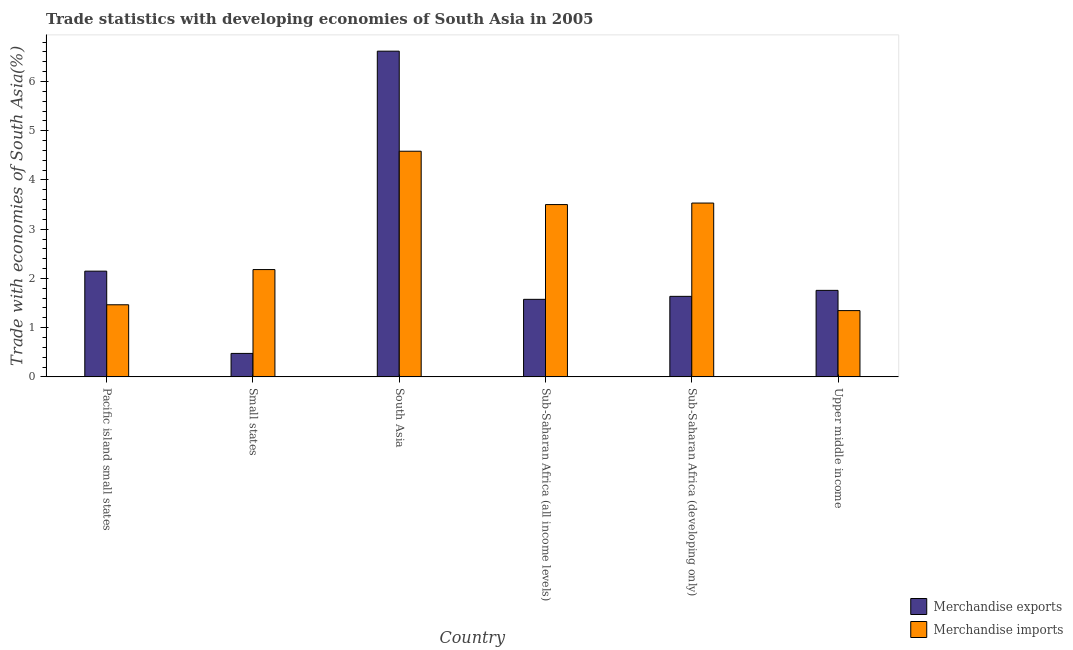How many different coloured bars are there?
Give a very brief answer. 2. Are the number of bars per tick equal to the number of legend labels?
Make the answer very short. Yes. Are the number of bars on each tick of the X-axis equal?
Your response must be concise. Yes. How many bars are there on the 6th tick from the right?
Make the answer very short. 2. What is the label of the 1st group of bars from the left?
Make the answer very short. Pacific island small states. In how many cases, is the number of bars for a given country not equal to the number of legend labels?
Your answer should be very brief. 0. What is the merchandise imports in Sub-Saharan Africa (developing only)?
Provide a succinct answer. 3.53. Across all countries, what is the maximum merchandise exports?
Give a very brief answer. 6.62. Across all countries, what is the minimum merchandise exports?
Keep it short and to the point. 0.48. In which country was the merchandise exports minimum?
Provide a short and direct response. Small states. What is the total merchandise exports in the graph?
Your answer should be very brief. 14.21. What is the difference between the merchandise exports in Pacific island small states and that in Sub-Saharan Africa (all income levels)?
Offer a terse response. 0.57. What is the difference between the merchandise imports in Sub-Saharan Africa (all income levels) and the merchandise exports in Upper middle income?
Provide a short and direct response. 1.74. What is the average merchandise imports per country?
Your response must be concise. 2.77. What is the difference between the merchandise exports and merchandise imports in Pacific island small states?
Offer a very short reply. 0.68. In how many countries, is the merchandise exports greater than 6 %?
Your answer should be very brief. 1. What is the ratio of the merchandise imports in Pacific island small states to that in Sub-Saharan Africa (developing only)?
Provide a short and direct response. 0.41. What is the difference between the highest and the second highest merchandise exports?
Provide a short and direct response. 4.47. What is the difference between the highest and the lowest merchandise exports?
Your answer should be compact. 6.14. Is the sum of the merchandise imports in South Asia and Sub-Saharan Africa (developing only) greater than the maximum merchandise exports across all countries?
Ensure brevity in your answer.  Yes. What does the 2nd bar from the left in Sub-Saharan Africa (developing only) represents?
Ensure brevity in your answer.  Merchandise imports. What does the 1st bar from the right in Small states represents?
Your response must be concise. Merchandise imports. How many bars are there?
Your answer should be very brief. 12. Are all the bars in the graph horizontal?
Your answer should be very brief. No. How many countries are there in the graph?
Ensure brevity in your answer.  6. Are the values on the major ticks of Y-axis written in scientific E-notation?
Your answer should be very brief. No. Does the graph contain any zero values?
Your answer should be very brief. No. Does the graph contain grids?
Your answer should be very brief. No. Where does the legend appear in the graph?
Provide a short and direct response. Bottom right. What is the title of the graph?
Give a very brief answer. Trade statistics with developing economies of South Asia in 2005. Does "Long-term debt" appear as one of the legend labels in the graph?
Your answer should be compact. No. What is the label or title of the X-axis?
Your answer should be very brief. Country. What is the label or title of the Y-axis?
Keep it short and to the point. Trade with economies of South Asia(%). What is the Trade with economies of South Asia(%) of Merchandise exports in Pacific island small states?
Provide a succinct answer. 2.15. What is the Trade with economies of South Asia(%) of Merchandise imports in Pacific island small states?
Keep it short and to the point. 1.46. What is the Trade with economies of South Asia(%) of Merchandise exports in Small states?
Give a very brief answer. 0.48. What is the Trade with economies of South Asia(%) of Merchandise imports in Small states?
Offer a terse response. 2.18. What is the Trade with economies of South Asia(%) in Merchandise exports in South Asia?
Your answer should be compact. 6.62. What is the Trade with economies of South Asia(%) in Merchandise imports in South Asia?
Ensure brevity in your answer.  4.58. What is the Trade with economies of South Asia(%) in Merchandise exports in Sub-Saharan Africa (all income levels)?
Ensure brevity in your answer.  1.57. What is the Trade with economies of South Asia(%) of Merchandise imports in Sub-Saharan Africa (all income levels)?
Provide a short and direct response. 3.5. What is the Trade with economies of South Asia(%) in Merchandise exports in Sub-Saharan Africa (developing only)?
Your answer should be very brief. 1.64. What is the Trade with economies of South Asia(%) of Merchandise imports in Sub-Saharan Africa (developing only)?
Your answer should be very brief. 3.53. What is the Trade with economies of South Asia(%) of Merchandise exports in Upper middle income?
Ensure brevity in your answer.  1.76. What is the Trade with economies of South Asia(%) in Merchandise imports in Upper middle income?
Your answer should be compact. 1.35. Across all countries, what is the maximum Trade with economies of South Asia(%) in Merchandise exports?
Offer a terse response. 6.62. Across all countries, what is the maximum Trade with economies of South Asia(%) in Merchandise imports?
Give a very brief answer. 4.58. Across all countries, what is the minimum Trade with economies of South Asia(%) of Merchandise exports?
Offer a very short reply. 0.48. Across all countries, what is the minimum Trade with economies of South Asia(%) in Merchandise imports?
Provide a succinct answer. 1.35. What is the total Trade with economies of South Asia(%) of Merchandise exports in the graph?
Offer a terse response. 14.21. What is the total Trade with economies of South Asia(%) in Merchandise imports in the graph?
Provide a short and direct response. 16.6. What is the difference between the Trade with economies of South Asia(%) in Merchandise exports in Pacific island small states and that in Small states?
Offer a very short reply. 1.67. What is the difference between the Trade with economies of South Asia(%) of Merchandise imports in Pacific island small states and that in Small states?
Your answer should be compact. -0.72. What is the difference between the Trade with economies of South Asia(%) in Merchandise exports in Pacific island small states and that in South Asia?
Give a very brief answer. -4.47. What is the difference between the Trade with economies of South Asia(%) in Merchandise imports in Pacific island small states and that in South Asia?
Your response must be concise. -3.12. What is the difference between the Trade with economies of South Asia(%) of Merchandise exports in Pacific island small states and that in Sub-Saharan Africa (all income levels)?
Keep it short and to the point. 0.57. What is the difference between the Trade with economies of South Asia(%) in Merchandise imports in Pacific island small states and that in Sub-Saharan Africa (all income levels)?
Provide a succinct answer. -2.04. What is the difference between the Trade with economies of South Asia(%) in Merchandise exports in Pacific island small states and that in Sub-Saharan Africa (developing only)?
Your answer should be very brief. 0.51. What is the difference between the Trade with economies of South Asia(%) of Merchandise imports in Pacific island small states and that in Sub-Saharan Africa (developing only)?
Your answer should be compact. -2.07. What is the difference between the Trade with economies of South Asia(%) of Merchandise exports in Pacific island small states and that in Upper middle income?
Your answer should be very brief. 0.39. What is the difference between the Trade with economies of South Asia(%) in Merchandise imports in Pacific island small states and that in Upper middle income?
Your answer should be compact. 0.12. What is the difference between the Trade with economies of South Asia(%) of Merchandise exports in Small states and that in South Asia?
Offer a very short reply. -6.14. What is the difference between the Trade with economies of South Asia(%) of Merchandise imports in Small states and that in South Asia?
Your response must be concise. -2.4. What is the difference between the Trade with economies of South Asia(%) in Merchandise exports in Small states and that in Sub-Saharan Africa (all income levels)?
Your response must be concise. -1.1. What is the difference between the Trade with economies of South Asia(%) in Merchandise imports in Small states and that in Sub-Saharan Africa (all income levels)?
Offer a terse response. -1.32. What is the difference between the Trade with economies of South Asia(%) in Merchandise exports in Small states and that in Sub-Saharan Africa (developing only)?
Your answer should be compact. -1.16. What is the difference between the Trade with economies of South Asia(%) of Merchandise imports in Small states and that in Sub-Saharan Africa (developing only)?
Make the answer very short. -1.35. What is the difference between the Trade with economies of South Asia(%) of Merchandise exports in Small states and that in Upper middle income?
Your response must be concise. -1.28. What is the difference between the Trade with economies of South Asia(%) in Merchandise imports in Small states and that in Upper middle income?
Ensure brevity in your answer.  0.83. What is the difference between the Trade with economies of South Asia(%) of Merchandise exports in South Asia and that in Sub-Saharan Africa (all income levels)?
Your answer should be very brief. 5.04. What is the difference between the Trade with economies of South Asia(%) of Merchandise imports in South Asia and that in Sub-Saharan Africa (all income levels)?
Ensure brevity in your answer.  1.08. What is the difference between the Trade with economies of South Asia(%) of Merchandise exports in South Asia and that in Sub-Saharan Africa (developing only)?
Offer a very short reply. 4.98. What is the difference between the Trade with economies of South Asia(%) of Merchandise imports in South Asia and that in Sub-Saharan Africa (developing only)?
Keep it short and to the point. 1.05. What is the difference between the Trade with economies of South Asia(%) in Merchandise exports in South Asia and that in Upper middle income?
Keep it short and to the point. 4.86. What is the difference between the Trade with economies of South Asia(%) of Merchandise imports in South Asia and that in Upper middle income?
Offer a very short reply. 3.24. What is the difference between the Trade with economies of South Asia(%) of Merchandise exports in Sub-Saharan Africa (all income levels) and that in Sub-Saharan Africa (developing only)?
Provide a succinct answer. -0.06. What is the difference between the Trade with economies of South Asia(%) of Merchandise imports in Sub-Saharan Africa (all income levels) and that in Sub-Saharan Africa (developing only)?
Provide a short and direct response. -0.03. What is the difference between the Trade with economies of South Asia(%) in Merchandise exports in Sub-Saharan Africa (all income levels) and that in Upper middle income?
Your answer should be very brief. -0.18. What is the difference between the Trade with economies of South Asia(%) of Merchandise imports in Sub-Saharan Africa (all income levels) and that in Upper middle income?
Provide a succinct answer. 2.15. What is the difference between the Trade with economies of South Asia(%) of Merchandise exports in Sub-Saharan Africa (developing only) and that in Upper middle income?
Offer a terse response. -0.12. What is the difference between the Trade with economies of South Asia(%) in Merchandise imports in Sub-Saharan Africa (developing only) and that in Upper middle income?
Keep it short and to the point. 2.18. What is the difference between the Trade with economies of South Asia(%) in Merchandise exports in Pacific island small states and the Trade with economies of South Asia(%) in Merchandise imports in Small states?
Your answer should be very brief. -0.03. What is the difference between the Trade with economies of South Asia(%) in Merchandise exports in Pacific island small states and the Trade with economies of South Asia(%) in Merchandise imports in South Asia?
Make the answer very short. -2.44. What is the difference between the Trade with economies of South Asia(%) of Merchandise exports in Pacific island small states and the Trade with economies of South Asia(%) of Merchandise imports in Sub-Saharan Africa (all income levels)?
Make the answer very short. -1.35. What is the difference between the Trade with economies of South Asia(%) in Merchandise exports in Pacific island small states and the Trade with economies of South Asia(%) in Merchandise imports in Sub-Saharan Africa (developing only)?
Provide a short and direct response. -1.38. What is the difference between the Trade with economies of South Asia(%) in Merchandise exports in Pacific island small states and the Trade with economies of South Asia(%) in Merchandise imports in Upper middle income?
Offer a terse response. 0.8. What is the difference between the Trade with economies of South Asia(%) in Merchandise exports in Small states and the Trade with economies of South Asia(%) in Merchandise imports in South Asia?
Give a very brief answer. -4.11. What is the difference between the Trade with economies of South Asia(%) in Merchandise exports in Small states and the Trade with economies of South Asia(%) in Merchandise imports in Sub-Saharan Africa (all income levels)?
Your answer should be very brief. -3.02. What is the difference between the Trade with economies of South Asia(%) in Merchandise exports in Small states and the Trade with economies of South Asia(%) in Merchandise imports in Sub-Saharan Africa (developing only)?
Ensure brevity in your answer.  -3.05. What is the difference between the Trade with economies of South Asia(%) of Merchandise exports in Small states and the Trade with economies of South Asia(%) of Merchandise imports in Upper middle income?
Your answer should be compact. -0.87. What is the difference between the Trade with economies of South Asia(%) in Merchandise exports in South Asia and the Trade with economies of South Asia(%) in Merchandise imports in Sub-Saharan Africa (all income levels)?
Provide a short and direct response. 3.12. What is the difference between the Trade with economies of South Asia(%) in Merchandise exports in South Asia and the Trade with economies of South Asia(%) in Merchandise imports in Sub-Saharan Africa (developing only)?
Give a very brief answer. 3.09. What is the difference between the Trade with economies of South Asia(%) in Merchandise exports in South Asia and the Trade with economies of South Asia(%) in Merchandise imports in Upper middle income?
Your answer should be very brief. 5.27. What is the difference between the Trade with economies of South Asia(%) in Merchandise exports in Sub-Saharan Africa (all income levels) and the Trade with economies of South Asia(%) in Merchandise imports in Sub-Saharan Africa (developing only)?
Your response must be concise. -1.96. What is the difference between the Trade with economies of South Asia(%) of Merchandise exports in Sub-Saharan Africa (all income levels) and the Trade with economies of South Asia(%) of Merchandise imports in Upper middle income?
Provide a short and direct response. 0.23. What is the difference between the Trade with economies of South Asia(%) of Merchandise exports in Sub-Saharan Africa (developing only) and the Trade with economies of South Asia(%) of Merchandise imports in Upper middle income?
Your response must be concise. 0.29. What is the average Trade with economies of South Asia(%) of Merchandise exports per country?
Keep it short and to the point. 2.37. What is the average Trade with economies of South Asia(%) of Merchandise imports per country?
Your response must be concise. 2.77. What is the difference between the Trade with economies of South Asia(%) of Merchandise exports and Trade with economies of South Asia(%) of Merchandise imports in Pacific island small states?
Offer a very short reply. 0.68. What is the difference between the Trade with economies of South Asia(%) of Merchandise exports and Trade with economies of South Asia(%) of Merchandise imports in Small states?
Provide a succinct answer. -1.7. What is the difference between the Trade with economies of South Asia(%) in Merchandise exports and Trade with economies of South Asia(%) in Merchandise imports in South Asia?
Make the answer very short. 2.03. What is the difference between the Trade with economies of South Asia(%) of Merchandise exports and Trade with economies of South Asia(%) of Merchandise imports in Sub-Saharan Africa (all income levels)?
Your answer should be very brief. -1.92. What is the difference between the Trade with economies of South Asia(%) in Merchandise exports and Trade with economies of South Asia(%) in Merchandise imports in Sub-Saharan Africa (developing only)?
Your answer should be compact. -1.9. What is the difference between the Trade with economies of South Asia(%) of Merchandise exports and Trade with economies of South Asia(%) of Merchandise imports in Upper middle income?
Provide a short and direct response. 0.41. What is the ratio of the Trade with economies of South Asia(%) of Merchandise exports in Pacific island small states to that in Small states?
Make the answer very short. 4.51. What is the ratio of the Trade with economies of South Asia(%) in Merchandise imports in Pacific island small states to that in Small states?
Provide a succinct answer. 0.67. What is the ratio of the Trade with economies of South Asia(%) of Merchandise exports in Pacific island small states to that in South Asia?
Your response must be concise. 0.32. What is the ratio of the Trade with economies of South Asia(%) of Merchandise imports in Pacific island small states to that in South Asia?
Your answer should be compact. 0.32. What is the ratio of the Trade with economies of South Asia(%) in Merchandise exports in Pacific island small states to that in Sub-Saharan Africa (all income levels)?
Offer a very short reply. 1.36. What is the ratio of the Trade with economies of South Asia(%) in Merchandise imports in Pacific island small states to that in Sub-Saharan Africa (all income levels)?
Your response must be concise. 0.42. What is the ratio of the Trade with economies of South Asia(%) of Merchandise exports in Pacific island small states to that in Sub-Saharan Africa (developing only)?
Provide a succinct answer. 1.31. What is the ratio of the Trade with economies of South Asia(%) of Merchandise imports in Pacific island small states to that in Sub-Saharan Africa (developing only)?
Offer a terse response. 0.41. What is the ratio of the Trade with economies of South Asia(%) in Merchandise exports in Pacific island small states to that in Upper middle income?
Offer a very short reply. 1.22. What is the ratio of the Trade with economies of South Asia(%) in Merchandise imports in Pacific island small states to that in Upper middle income?
Your answer should be compact. 1.09. What is the ratio of the Trade with economies of South Asia(%) of Merchandise exports in Small states to that in South Asia?
Your answer should be compact. 0.07. What is the ratio of the Trade with economies of South Asia(%) in Merchandise imports in Small states to that in South Asia?
Provide a succinct answer. 0.48. What is the ratio of the Trade with economies of South Asia(%) of Merchandise exports in Small states to that in Sub-Saharan Africa (all income levels)?
Offer a very short reply. 0.3. What is the ratio of the Trade with economies of South Asia(%) of Merchandise imports in Small states to that in Sub-Saharan Africa (all income levels)?
Give a very brief answer. 0.62. What is the ratio of the Trade with economies of South Asia(%) in Merchandise exports in Small states to that in Sub-Saharan Africa (developing only)?
Your response must be concise. 0.29. What is the ratio of the Trade with economies of South Asia(%) of Merchandise imports in Small states to that in Sub-Saharan Africa (developing only)?
Provide a short and direct response. 0.62. What is the ratio of the Trade with economies of South Asia(%) of Merchandise exports in Small states to that in Upper middle income?
Ensure brevity in your answer.  0.27. What is the ratio of the Trade with economies of South Asia(%) in Merchandise imports in Small states to that in Upper middle income?
Provide a succinct answer. 1.62. What is the ratio of the Trade with economies of South Asia(%) in Merchandise exports in South Asia to that in Sub-Saharan Africa (all income levels)?
Give a very brief answer. 4.2. What is the ratio of the Trade with economies of South Asia(%) of Merchandise imports in South Asia to that in Sub-Saharan Africa (all income levels)?
Keep it short and to the point. 1.31. What is the ratio of the Trade with economies of South Asia(%) in Merchandise exports in South Asia to that in Sub-Saharan Africa (developing only)?
Make the answer very short. 4.05. What is the ratio of the Trade with economies of South Asia(%) in Merchandise imports in South Asia to that in Sub-Saharan Africa (developing only)?
Provide a short and direct response. 1.3. What is the ratio of the Trade with economies of South Asia(%) in Merchandise exports in South Asia to that in Upper middle income?
Provide a short and direct response. 3.77. What is the ratio of the Trade with economies of South Asia(%) in Merchandise imports in South Asia to that in Upper middle income?
Provide a short and direct response. 3.4. What is the ratio of the Trade with economies of South Asia(%) of Merchandise exports in Sub-Saharan Africa (all income levels) to that in Sub-Saharan Africa (developing only)?
Keep it short and to the point. 0.96. What is the ratio of the Trade with economies of South Asia(%) of Merchandise imports in Sub-Saharan Africa (all income levels) to that in Sub-Saharan Africa (developing only)?
Offer a terse response. 0.99. What is the ratio of the Trade with economies of South Asia(%) of Merchandise exports in Sub-Saharan Africa (all income levels) to that in Upper middle income?
Offer a very short reply. 0.9. What is the ratio of the Trade with economies of South Asia(%) of Merchandise imports in Sub-Saharan Africa (all income levels) to that in Upper middle income?
Keep it short and to the point. 2.6. What is the ratio of the Trade with economies of South Asia(%) in Merchandise exports in Sub-Saharan Africa (developing only) to that in Upper middle income?
Your answer should be very brief. 0.93. What is the ratio of the Trade with economies of South Asia(%) of Merchandise imports in Sub-Saharan Africa (developing only) to that in Upper middle income?
Offer a terse response. 2.62. What is the difference between the highest and the second highest Trade with economies of South Asia(%) in Merchandise exports?
Give a very brief answer. 4.47. What is the difference between the highest and the second highest Trade with economies of South Asia(%) in Merchandise imports?
Provide a succinct answer. 1.05. What is the difference between the highest and the lowest Trade with economies of South Asia(%) in Merchandise exports?
Provide a short and direct response. 6.14. What is the difference between the highest and the lowest Trade with economies of South Asia(%) in Merchandise imports?
Your answer should be very brief. 3.24. 